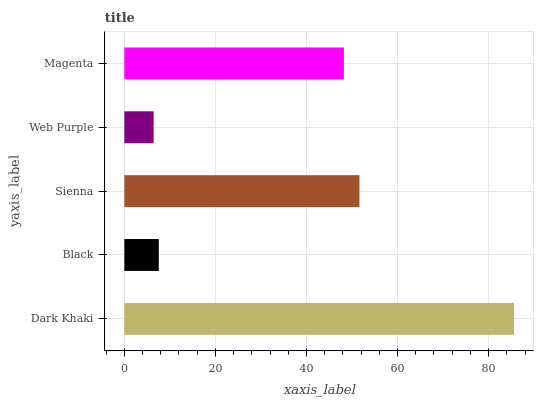Is Web Purple the minimum?
Answer yes or no. Yes. Is Dark Khaki the maximum?
Answer yes or no. Yes. Is Black the minimum?
Answer yes or no. No. Is Black the maximum?
Answer yes or no. No. Is Dark Khaki greater than Black?
Answer yes or no. Yes. Is Black less than Dark Khaki?
Answer yes or no. Yes. Is Black greater than Dark Khaki?
Answer yes or no. No. Is Dark Khaki less than Black?
Answer yes or no. No. Is Magenta the high median?
Answer yes or no. Yes. Is Magenta the low median?
Answer yes or no. Yes. Is Dark Khaki the high median?
Answer yes or no. No. Is Dark Khaki the low median?
Answer yes or no. No. 